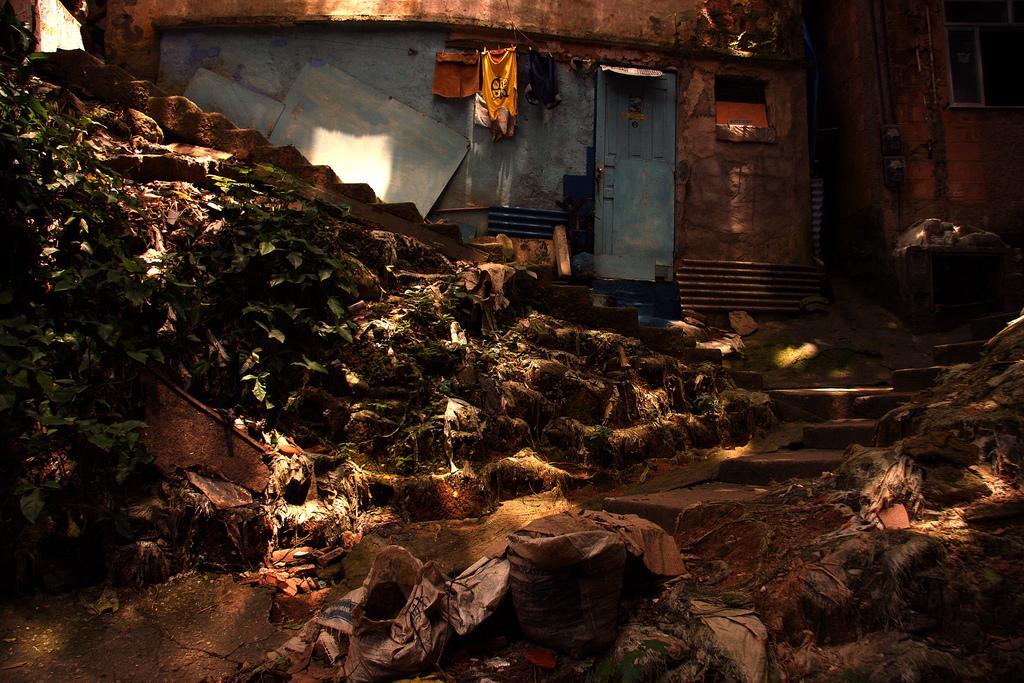How would you summarize this image in a sentence or two? The picture is clicked on the street outside a house. In the foreground of the picture there are plants and waste materials. In the center of the picture there is a house. In the center there are clothes. On the right there is a building. 